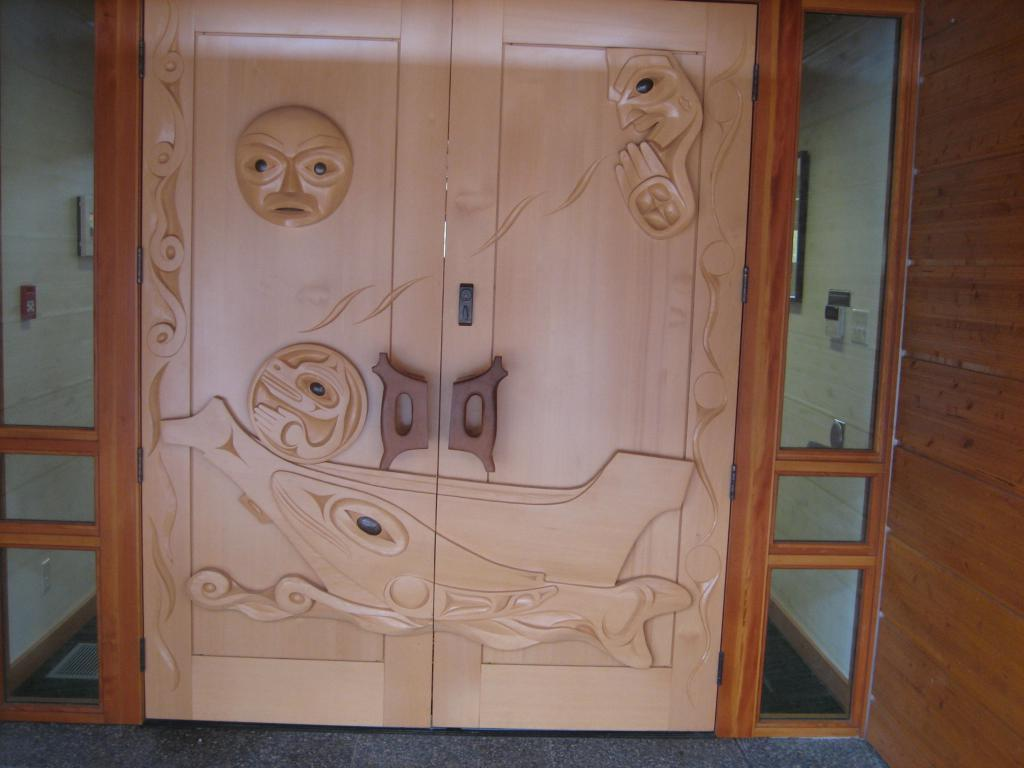What is located in the center of the image? There are doors in the center of the image. What can be observed about the doors? The doors have designs on them. Can you describe the elements on both sides of the image? Unfortunately, the provided facts do not give enough information to describe the elements on both sides of the image. What type of steel is used to construct the oven in the image? There is no oven present in the image, so it is not possible to determine the type of steel used in its construction. 